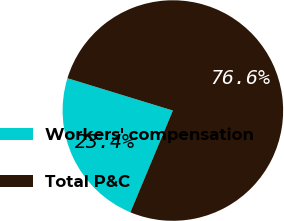<chart> <loc_0><loc_0><loc_500><loc_500><pie_chart><fcel>Workers' compensation<fcel>Total P&C<nl><fcel>23.44%<fcel>76.56%<nl></chart> 